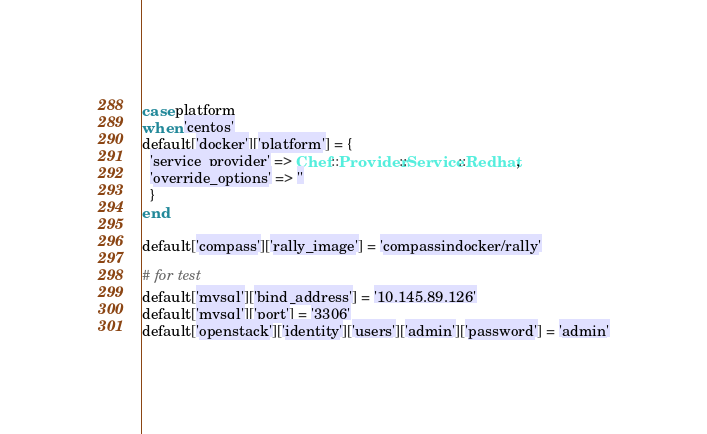<code> <loc_0><loc_0><loc_500><loc_500><_Ruby_>case platform
when 'centos'
default['docker']['platform'] = {
  'service_provider' => Chef::Provider::Service::Redhat,
  'override_options' => ''
  }
end

default['compass']['rally_image'] = 'compassindocker/rally'

# for test
default['mysql']['bind_address'] = '10.145.89.126'
default['mysql']['port'] = '3306'
default['openstack']['identity']['users']['admin']['password'] = 'admin'
</code> 